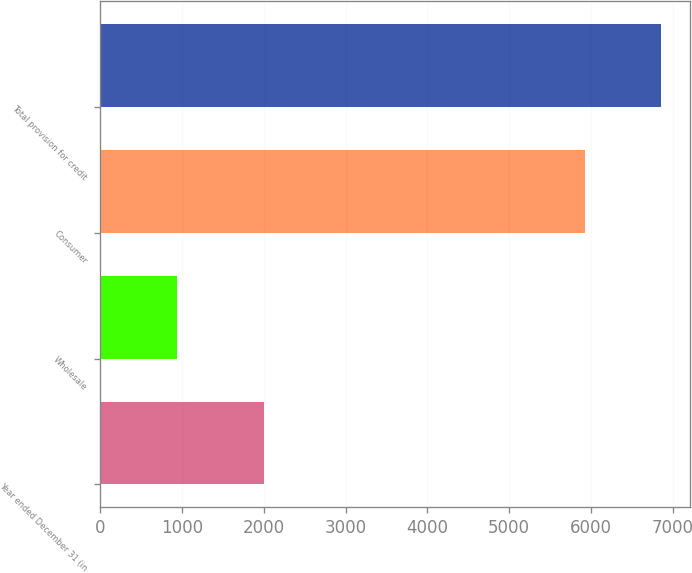<chart> <loc_0><loc_0><loc_500><loc_500><bar_chart><fcel>Year ended December 31 (in<fcel>Wholesale<fcel>Consumer<fcel>Total provision for credit<nl><fcel>2007<fcel>934<fcel>5930<fcel>6864<nl></chart> 